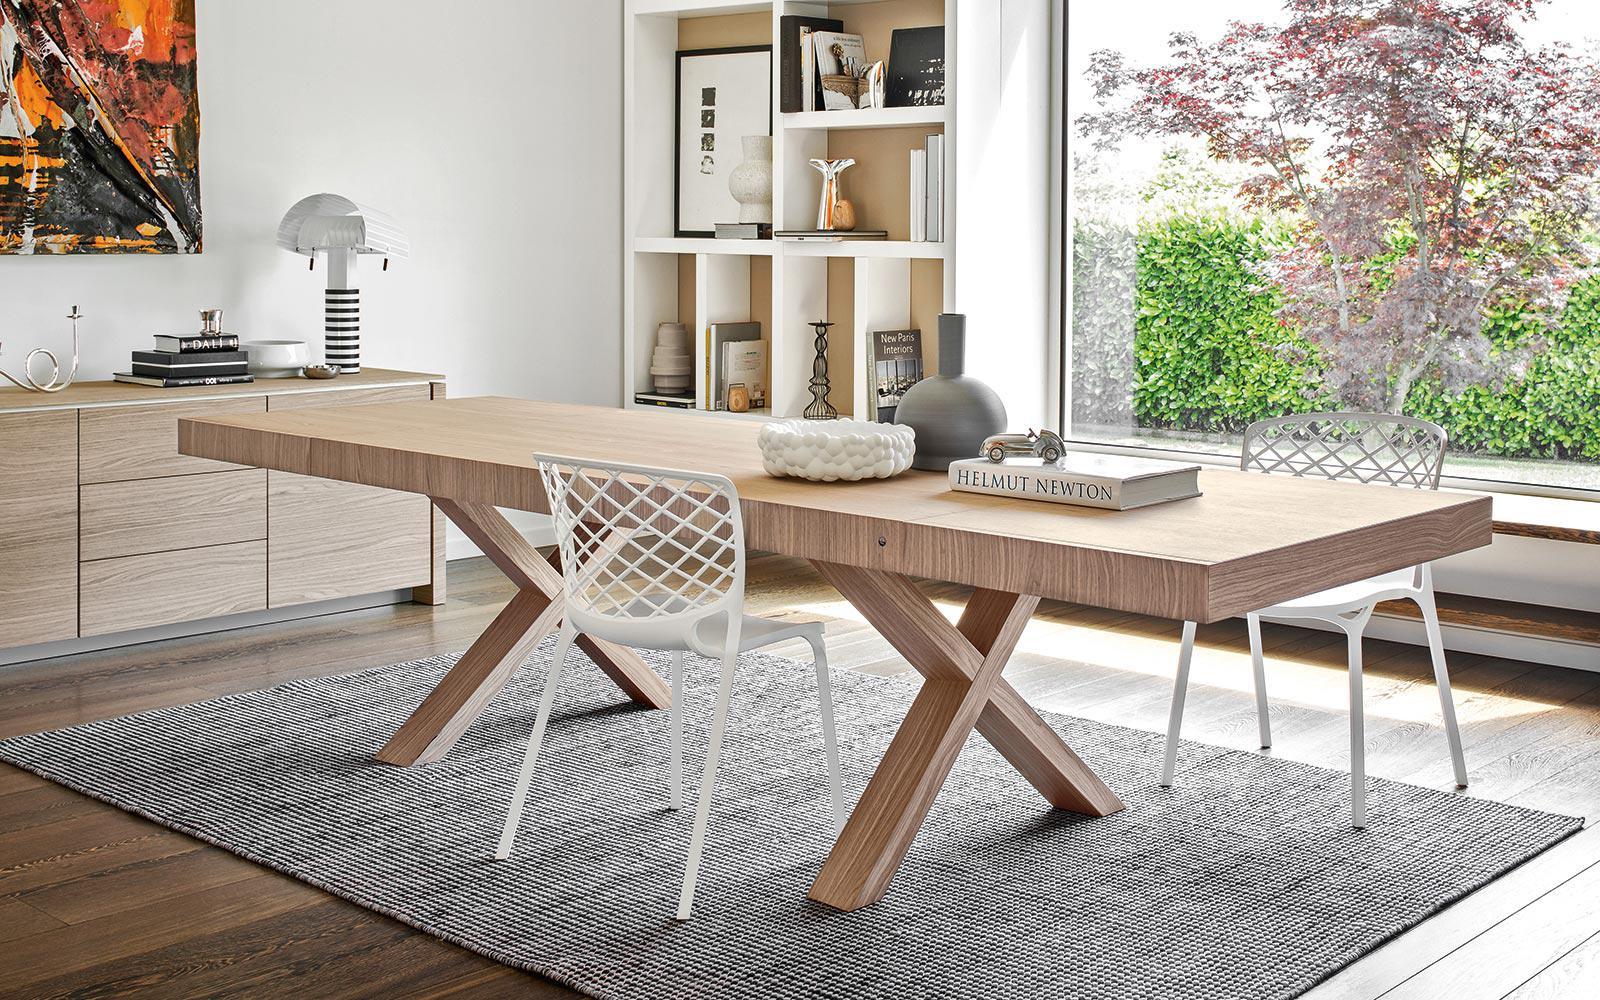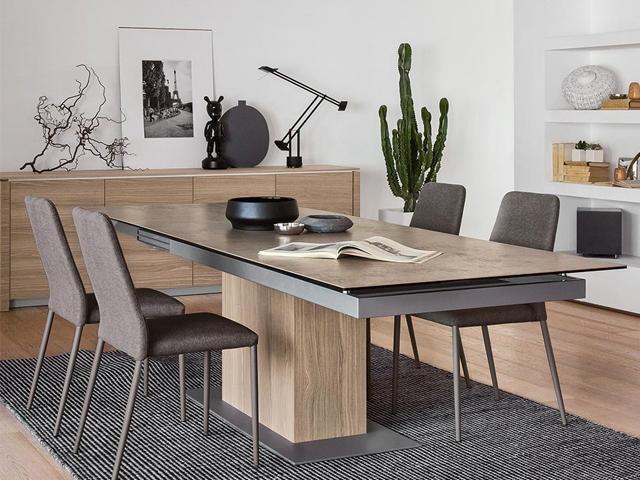The first image is the image on the left, the second image is the image on the right. Analyze the images presented: Is the assertion "The legs on the table in one of the images is shaped like the letter """"x""""." valid? Answer yes or no. Yes. The first image is the image on the left, the second image is the image on the right. Evaluate the accuracy of this statement regarding the images: "One image shows two white chairs with criss-crossed backs at a light wood table with X-shaped legs, and the other image shows a dark-topped rectangular table with a rectangular pedestal base.". Is it true? Answer yes or no. Yes. 